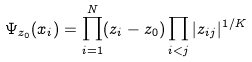Convert formula to latex. <formula><loc_0><loc_0><loc_500><loc_500>\Psi _ { z _ { 0 } } ( x _ { i } ) = \prod _ { i = 1 } ^ { N } ( z _ { i } - z _ { 0 } ) \prod _ { i < j } | z _ { i j } { | } ^ { 1 / K }</formula> 